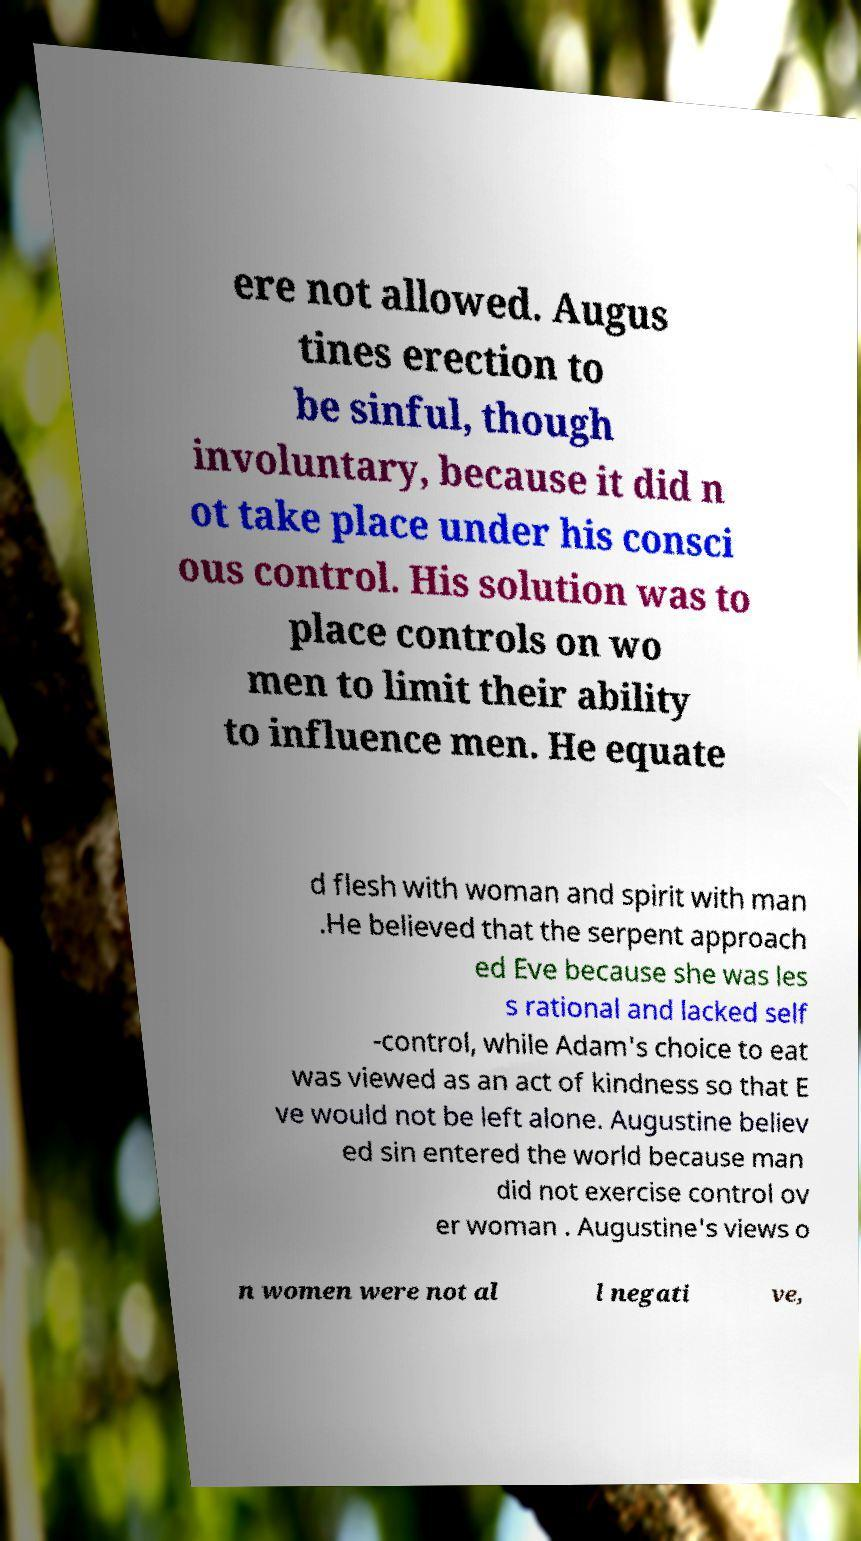What messages or text are displayed in this image? I need them in a readable, typed format. ere not allowed. Augus tines erection to be sinful, though involuntary, because it did n ot take place under his consci ous control. His solution was to place controls on wo men to limit their ability to influence men. He equate d flesh with woman and spirit with man .He believed that the serpent approach ed Eve because she was les s rational and lacked self -control, while Adam's choice to eat was viewed as an act of kindness so that E ve would not be left alone. Augustine believ ed sin entered the world because man did not exercise control ov er woman . Augustine's views o n women were not al l negati ve, 